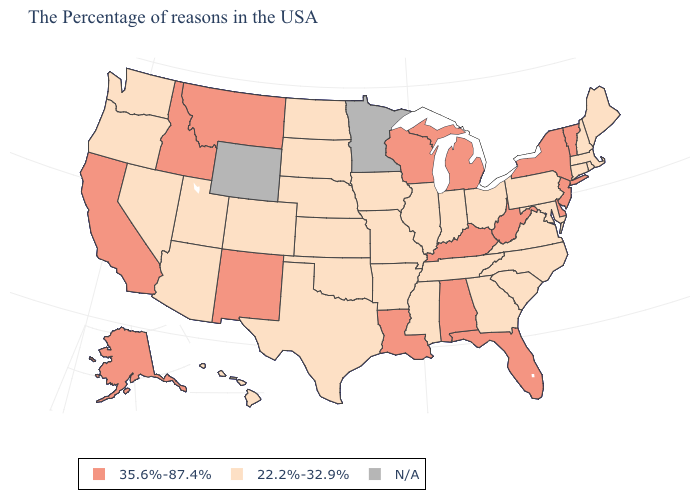Name the states that have a value in the range 35.6%-87.4%?
Write a very short answer. Vermont, New York, New Jersey, Delaware, West Virginia, Florida, Michigan, Kentucky, Alabama, Wisconsin, Louisiana, New Mexico, Montana, Idaho, California, Alaska. What is the value of Arkansas?
Keep it brief. 22.2%-32.9%. Among the states that border Pennsylvania , which have the highest value?
Keep it brief. New York, New Jersey, Delaware, West Virginia. What is the highest value in states that border Vermont?
Concise answer only. 35.6%-87.4%. What is the highest value in the USA?
Quick response, please. 35.6%-87.4%. Is the legend a continuous bar?
Be succinct. No. Does the map have missing data?
Concise answer only. Yes. Name the states that have a value in the range N/A?
Give a very brief answer. Minnesota, Wyoming. Which states have the lowest value in the Northeast?
Short answer required. Maine, Massachusetts, Rhode Island, New Hampshire, Connecticut, Pennsylvania. What is the value of Indiana?
Short answer required. 22.2%-32.9%. Does Colorado have the highest value in the USA?
Concise answer only. No. Among the states that border Delaware , which have the highest value?
Short answer required. New Jersey. Among the states that border Oklahoma , which have the highest value?
Be succinct. New Mexico. 